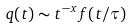<formula> <loc_0><loc_0><loc_500><loc_500>q ( t ) \sim t ^ { - x } f ( t / \tau )</formula> 